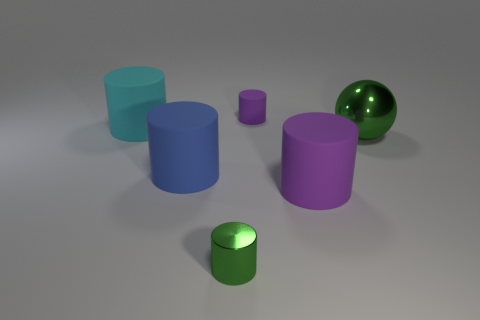Subtract 1 cylinders. How many cylinders are left? 4 Subtract all red cylinders. Subtract all green blocks. How many cylinders are left? 5 Add 4 blue things. How many objects exist? 10 Subtract all spheres. How many objects are left? 5 Subtract 0 brown cubes. How many objects are left? 6 Subtract all large cyan balls. Subtract all big cyan objects. How many objects are left? 5 Add 5 purple objects. How many purple objects are left? 7 Add 2 cyan metal cylinders. How many cyan metal cylinders exist? 2 